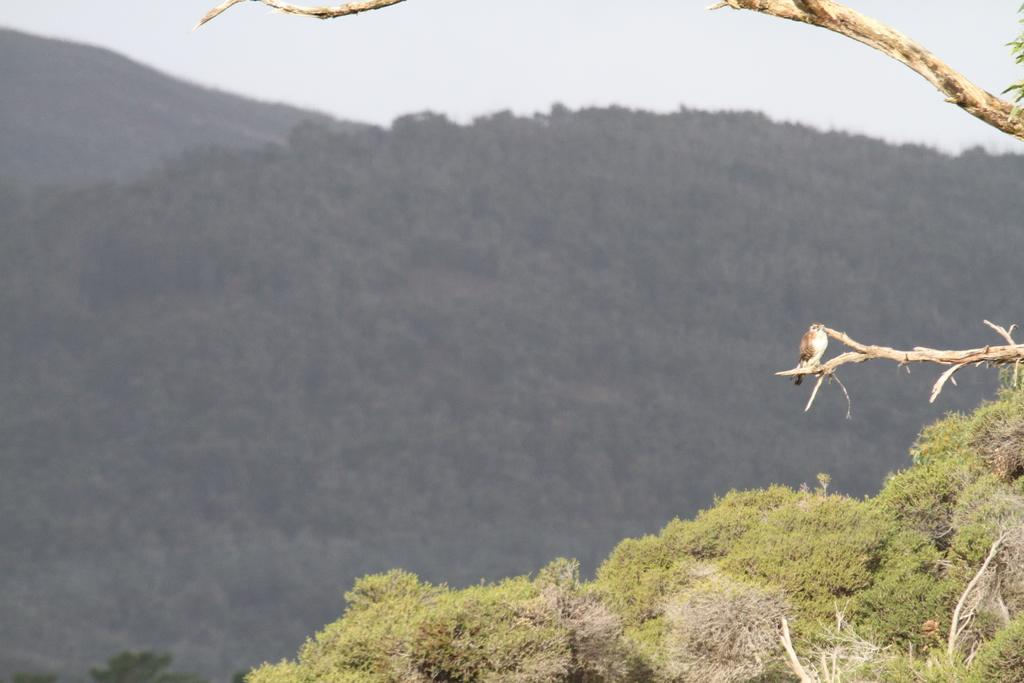What animal can be seen on a tree branch in the image? There is a bird on a tree branch in the image. What type of landscape is visible in the image? Mountains are visible in the image. What type of vegetation is present in the image? There is grass in the image. What is visible in the background of the image? The sky is visible in the background of the image. Can you tell me how many fish are swimming in the grass in the image? There are no fish present in the image; it features a bird on a tree branch, mountains, grass, and the sky. 